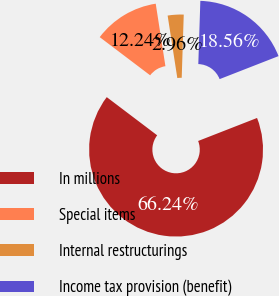Convert chart. <chart><loc_0><loc_0><loc_500><loc_500><pie_chart><fcel>In millions<fcel>Special items<fcel>Internal restructurings<fcel>Income tax provision (benefit)<nl><fcel>66.24%<fcel>12.24%<fcel>2.96%<fcel>18.56%<nl></chart> 